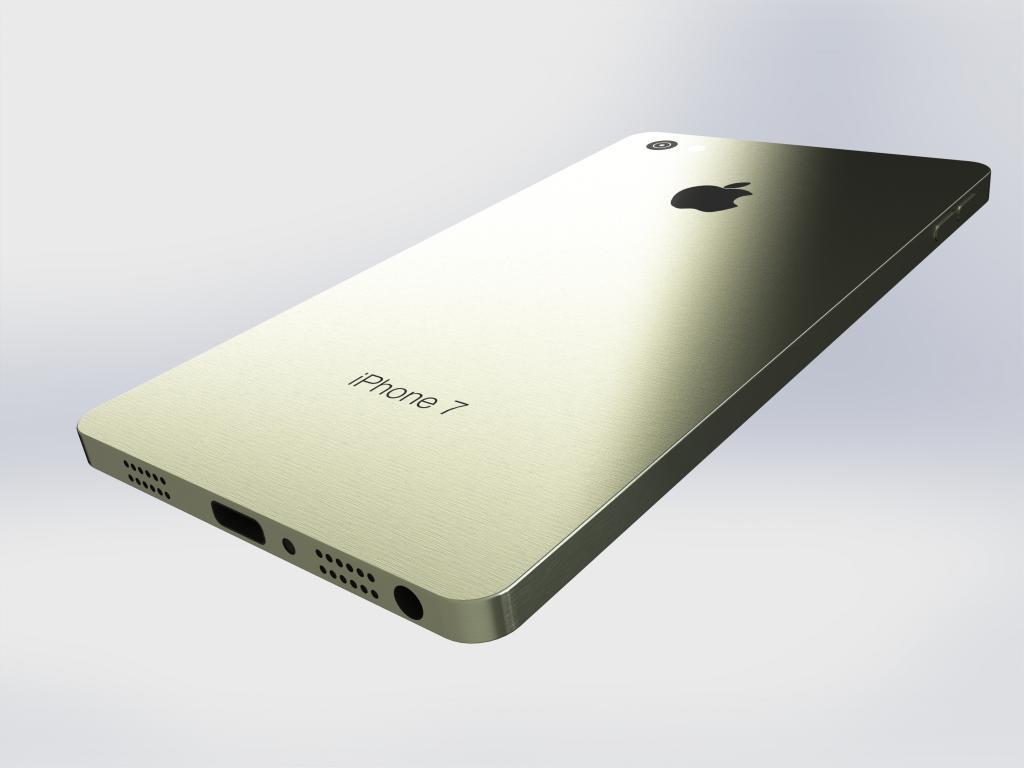<image>
Give a short and clear explanation of the subsequent image. An iPhone 7 against a white back drop. 